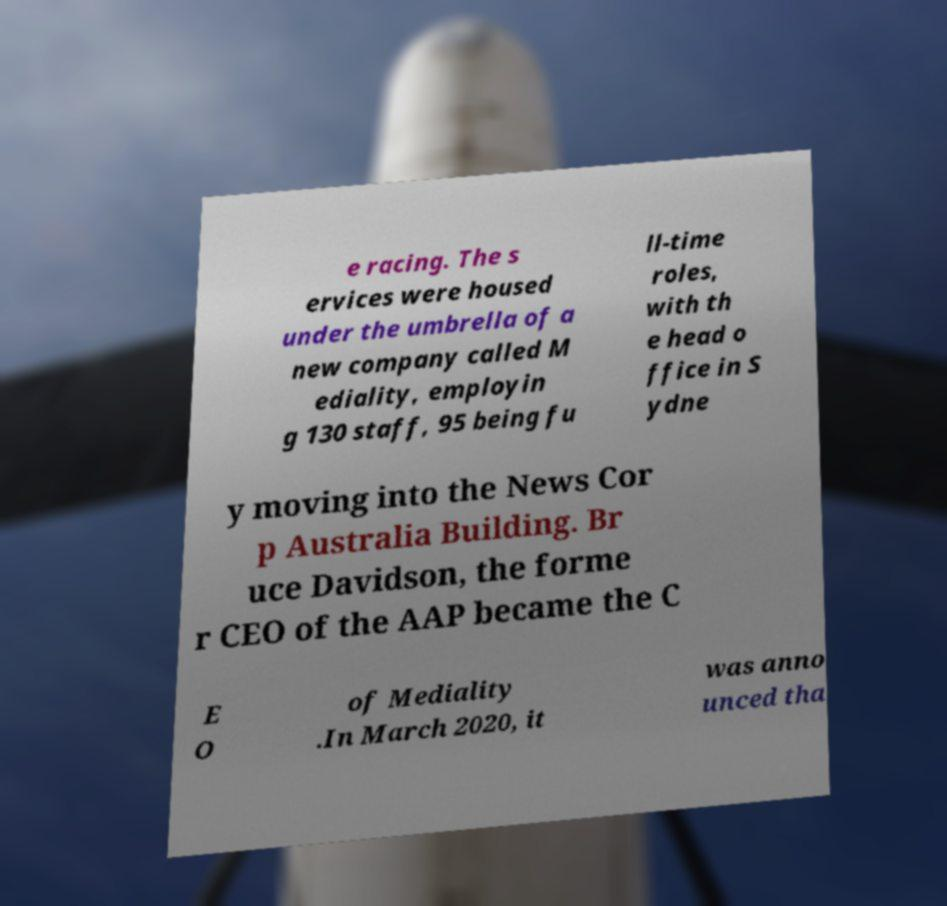For documentation purposes, I need the text within this image transcribed. Could you provide that? e racing. The s ervices were housed under the umbrella of a new company called M ediality, employin g 130 staff, 95 being fu ll-time roles, with th e head o ffice in S ydne y moving into the News Cor p Australia Building. Br uce Davidson, the forme r CEO of the AAP became the C E O of Mediality .In March 2020, it was anno unced tha 